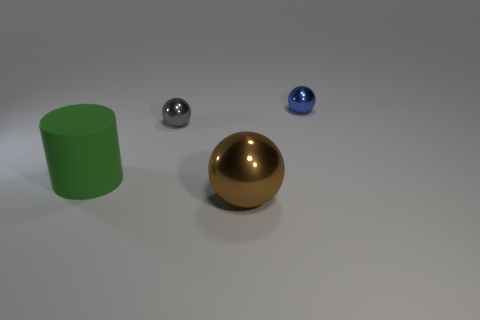How many things are either objects that are on the left side of the big sphere or objects that are right of the large metal ball?
Offer a very short reply. 3. Is the matte object the same size as the brown metallic ball?
Your response must be concise. Yes. Do the shiny thing in front of the green object and the tiny shiny thing behind the gray metallic object have the same shape?
Offer a terse response. Yes. The rubber object is what size?
Make the answer very short. Large. There is a ball on the right side of the metal thing that is in front of the large thing that is behind the brown ball; what is it made of?
Keep it short and to the point. Metal. What number of brown objects are either small things or big objects?
Offer a very short reply. 1. What is the material of the big thing that is in front of the green matte cylinder?
Offer a very short reply. Metal. Do the big brown sphere that is in front of the green object and the green cylinder have the same material?
Ensure brevity in your answer.  No. What shape is the small blue object?
Your response must be concise. Sphere. There is a large green rubber cylinder behind the sphere that is in front of the green object; how many blue metal balls are in front of it?
Your answer should be very brief. 0. 